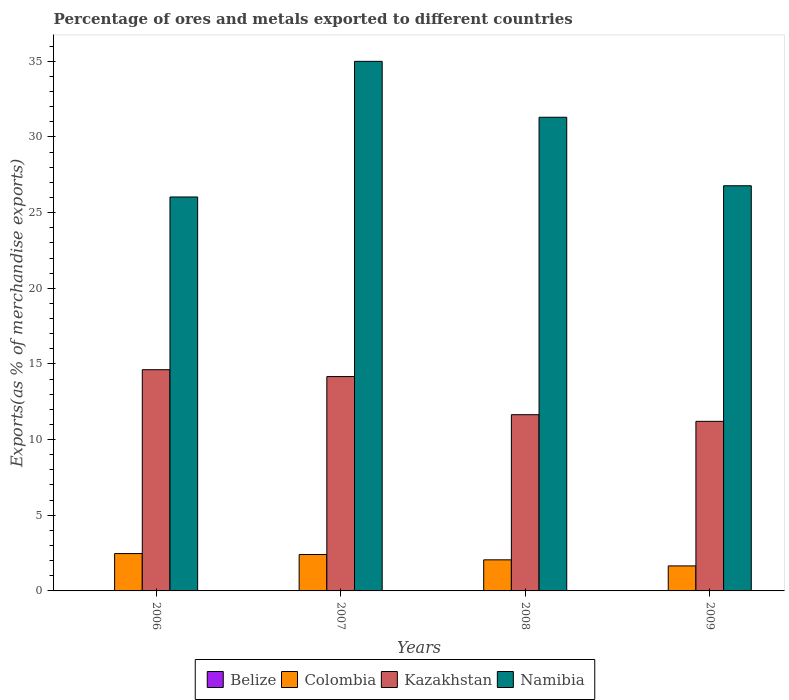Are the number of bars per tick equal to the number of legend labels?
Your answer should be compact. Yes. How many bars are there on the 2nd tick from the left?
Your answer should be very brief. 4. In how many cases, is the number of bars for a given year not equal to the number of legend labels?
Your response must be concise. 0. What is the percentage of exports to different countries in Kazakhstan in 2008?
Offer a very short reply. 11.64. Across all years, what is the maximum percentage of exports to different countries in Namibia?
Keep it short and to the point. 34.99. Across all years, what is the minimum percentage of exports to different countries in Namibia?
Offer a terse response. 26.03. In which year was the percentage of exports to different countries in Kazakhstan maximum?
Make the answer very short. 2006. What is the total percentage of exports to different countries in Colombia in the graph?
Your response must be concise. 8.58. What is the difference between the percentage of exports to different countries in Belize in 2007 and that in 2009?
Provide a succinct answer. 0. What is the difference between the percentage of exports to different countries in Colombia in 2007 and the percentage of exports to different countries in Belize in 2006?
Give a very brief answer. 2.4. What is the average percentage of exports to different countries in Colombia per year?
Provide a succinct answer. 2.15. In the year 2008, what is the difference between the percentage of exports to different countries in Colombia and percentage of exports to different countries in Belize?
Make the answer very short. 2.05. What is the ratio of the percentage of exports to different countries in Kazakhstan in 2007 to that in 2008?
Offer a very short reply. 1.22. Is the percentage of exports to different countries in Colombia in 2006 less than that in 2007?
Ensure brevity in your answer.  No. Is the difference between the percentage of exports to different countries in Colombia in 2008 and 2009 greater than the difference between the percentage of exports to different countries in Belize in 2008 and 2009?
Provide a short and direct response. Yes. What is the difference between the highest and the second highest percentage of exports to different countries in Namibia?
Provide a succinct answer. 3.69. What is the difference between the highest and the lowest percentage of exports to different countries in Namibia?
Offer a terse response. 8.96. Is the sum of the percentage of exports to different countries in Kazakhstan in 2007 and 2008 greater than the maximum percentage of exports to different countries in Colombia across all years?
Offer a terse response. Yes. Is it the case that in every year, the sum of the percentage of exports to different countries in Colombia and percentage of exports to different countries in Kazakhstan is greater than the sum of percentage of exports to different countries in Namibia and percentage of exports to different countries in Belize?
Keep it short and to the point. Yes. What does the 2nd bar from the left in 2006 represents?
Your answer should be very brief. Colombia. What does the 2nd bar from the right in 2008 represents?
Your response must be concise. Kazakhstan. Is it the case that in every year, the sum of the percentage of exports to different countries in Belize and percentage of exports to different countries in Kazakhstan is greater than the percentage of exports to different countries in Colombia?
Your answer should be compact. Yes. Are all the bars in the graph horizontal?
Make the answer very short. No. How many years are there in the graph?
Your response must be concise. 4. What is the difference between two consecutive major ticks on the Y-axis?
Offer a terse response. 5. Are the values on the major ticks of Y-axis written in scientific E-notation?
Provide a succinct answer. No. Does the graph contain any zero values?
Give a very brief answer. No. Does the graph contain grids?
Offer a terse response. No. Where does the legend appear in the graph?
Keep it short and to the point. Bottom center. How many legend labels are there?
Offer a very short reply. 4. What is the title of the graph?
Offer a terse response. Percentage of ores and metals exported to different countries. Does "Ethiopia" appear as one of the legend labels in the graph?
Offer a very short reply. No. What is the label or title of the Y-axis?
Offer a very short reply. Exports(as % of merchandise exports). What is the Exports(as % of merchandise exports) in Belize in 2006?
Give a very brief answer. 0. What is the Exports(as % of merchandise exports) of Colombia in 2006?
Provide a succinct answer. 2.47. What is the Exports(as % of merchandise exports) in Kazakhstan in 2006?
Your answer should be very brief. 14.62. What is the Exports(as % of merchandise exports) in Namibia in 2006?
Offer a very short reply. 26.03. What is the Exports(as % of merchandise exports) of Belize in 2007?
Your answer should be very brief. 0. What is the Exports(as % of merchandise exports) of Colombia in 2007?
Provide a short and direct response. 2.41. What is the Exports(as % of merchandise exports) of Kazakhstan in 2007?
Ensure brevity in your answer.  14.16. What is the Exports(as % of merchandise exports) of Namibia in 2007?
Provide a short and direct response. 34.99. What is the Exports(as % of merchandise exports) in Belize in 2008?
Ensure brevity in your answer.  0. What is the Exports(as % of merchandise exports) in Colombia in 2008?
Give a very brief answer. 2.05. What is the Exports(as % of merchandise exports) of Kazakhstan in 2008?
Your answer should be very brief. 11.64. What is the Exports(as % of merchandise exports) of Namibia in 2008?
Offer a very short reply. 31.3. What is the Exports(as % of merchandise exports) of Belize in 2009?
Offer a terse response. 0. What is the Exports(as % of merchandise exports) in Colombia in 2009?
Provide a short and direct response. 1.65. What is the Exports(as % of merchandise exports) in Kazakhstan in 2009?
Your answer should be very brief. 11.21. What is the Exports(as % of merchandise exports) of Namibia in 2009?
Your response must be concise. 26.77. Across all years, what is the maximum Exports(as % of merchandise exports) in Belize?
Ensure brevity in your answer.  0. Across all years, what is the maximum Exports(as % of merchandise exports) in Colombia?
Make the answer very short. 2.47. Across all years, what is the maximum Exports(as % of merchandise exports) of Kazakhstan?
Your answer should be very brief. 14.62. Across all years, what is the maximum Exports(as % of merchandise exports) of Namibia?
Make the answer very short. 34.99. Across all years, what is the minimum Exports(as % of merchandise exports) in Belize?
Your answer should be very brief. 0. Across all years, what is the minimum Exports(as % of merchandise exports) of Colombia?
Provide a short and direct response. 1.65. Across all years, what is the minimum Exports(as % of merchandise exports) of Kazakhstan?
Your response must be concise. 11.21. Across all years, what is the minimum Exports(as % of merchandise exports) of Namibia?
Offer a terse response. 26.03. What is the total Exports(as % of merchandise exports) in Belize in the graph?
Keep it short and to the point. 0.01. What is the total Exports(as % of merchandise exports) of Colombia in the graph?
Make the answer very short. 8.58. What is the total Exports(as % of merchandise exports) in Kazakhstan in the graph?
Give a very brief answer. 51.63. What is the total Exports(as % of merchandise exports) in Namibia in the graph?
Offer a terse response. 119.1. What is the difference between the Exports(as % of merchandise exports) in Belize in 2006 and that in 2007?
Give a very brief answer. -0. What is the difference between the Exports(as % of merchandise exports) of Colombia in 2006 and that in 2007?
Your answer should be compact. 0.06. What is the difference between the Exports(as % of merchandise exports) of Kazakhstan in 2006 and that in 2007?
Make the answer very short. 0.45. What is the difference between the Exports(as % of merchandise exports) of Namibia in 2006 and that in 2007?
Your answer should be very brief. -8.96. What is the difference between the Exports(as % of merchandise exports) in Belize in 2006 and that in 2008?
Ensure brevity in your answer.  -0. What is the difference between the Exports(as % of merchandise exports) of Colombia in 2006 and that in 2008?
Keep it short and to the point. 0.41. What is the difference between the Exports(as % of merchandise exports) of Kazakhstan in 2006 and that in 2008?
Give a very brief answer. 2.97. What is the difference between the Exports(as % of merchandise exports) in Namibia in 2006 and that in 2008?
Your answer should be compact. -5.27. What is the difference between the Exports(as % of merchandise exports) in Belize in 2006 and that in 2009?
Your answer should be compact. -0. What is the difference between the Exports(as % of merchandise exports) in Colombia in 2006 and that in 2009?
Your response must be concise. 0.81. What is the difference between the Exports(as % of merchandise exports) in Kazakhstan in 2006 and that in 2009?
Your answer should be compact. 3.41. What is the difference between the Exports(as % of merchandise exports) of Namibia in 2006 and that in 2009?
Your answer should be compact. -0.74. What is the difference between the Exports(as % of merchandise exports) in Belize in 2007 and that in 2008?
Your response must be concise. -0. What is the difference between the Exports(as % of merchandise exports) of Colombia in 2007 and that in 2008?
Your response must be concise. 0.35. What is the difference between the Exports(as % of merchandise exports) of Kazakhstan in 2007 and that in 2008?
Your answer should be compact. 2.52. What is the difference between the Exports(as % of merchandise exports) of Namibia in 2007 and that in 2008?
Your response must be concise. 3.69. What is the difference between the Exports(as % of merchandise exports) in Belize in 2007 and that in 2009?
Offer a very short reply. 0. What is the difference between the Exports(as % of merchandise exports) of Colombia in 2007 and that in 2009?
Make the answer very short. 0.75. What is the difference between the Exports(as % of merchandise exports) in Kazakhstan in 2007 and that in 2009?
Make the answer very short. 2.96. What is the difference between the Exports(as % of merchandise exports) of Namibia in 2007 and that in 2009?
Provide a succinct answer. 8.22. What is the difference between the Exports(as % of merchandise exports) in Belize in 2008 and that in 2009?
Offer a terse response. 0. What is the difference between the Exports(as % of merchandise exports) of Colombia in 2008 and that in 2009?
Offer a very short reply. 0.4. What is the difference between the Exports(as % of merchandise exports) of Kazakhstan in 2008 and that in 2009?
Your answer should be compact. 0.44. What is the difference between the Exports(as % of merchandise exports) in Namibia in 2008 and that in 2009?
Make the answer very short. 4.53. What is the difference between the Exports(as % of merchandise exports) in Belize in 2006 and the Exports(as % of merchandise exports) in Colombia in 2007?
Give a very brief answer. -2.4. What is the difference between the Exports(as % of merchandise exports) of Belize in 2006 and the Exports(as % of merchandise exports) of Kazakhstan in 2007?
Give a very brief answer. -14.16. What is the difference between the Exports(as % of merchandise exports) in Belize in 2006 and the Exports(as % of merchandise exports) in Namibia in 2007?
Make the answer very short. -34.99. What is the difference between the Exports(as % of merchandise exports) of Colombia in 2006 and the Exports(as % of merchandise exports) of Kazakhstan in 2007?
Keep it short and to the point. -11.7. What is the difference between the Exports(as % of merchandise exports) of Colombia in 2006 and the Exports(as % of merchandise exports) of Namibia in 2007?
Provide a short and direct response. -32.53. What is the difference between the Exports(as % of merchandise exports) of Kazakhstan in 2006 and the Exports(as % of merchandise exports) of Namibia in 2007?
Your response must be concise. -20.38. What is the difference between the Exports(as % of merchandise exports) of Belize in 2006 and the Exports(as % of merchandise exports) of Colombia in 2008?
Offer a terse response. -2.05. What is the difference between the Exports(as % of merchandise exports) of Belize in 2006 and the Exports(as % of merchandise exports) of Kazakhstan in 2008?
Offer a terse response. -11.64. What is the difference between the Exports(as % of merchandise exports) in Belize in 2006 and the Exports(as % of merchandise exports) in Namibia in 2008?
Keep it short and to the point. -31.3. What is the difference between the Exports(as % of merchandise exports) in Colombia in 2006 and the Exports(as % of merchandise exports) in Kazakhstan in 2008?
Make the answer very short. -9.18. What is the difference between the Exports(as % of merchandise exports) in Colombia in 2006 and the Exports(as % of merchandise exports) in Namibia in 2008?
Offer a terse response. -28.83. What is the difference between the Exports(as % of merchandise exports) of Kazakhstan in 2006 and the Exports(as % of merchandise exports) of Namibia in 2008?
Give a very brief answer. -16.68. What is the difference between the Exports(as % of merchandise exports) of Belize in 2006 and the Exports(as % of merchandise exports) of Colombia in 2009?
Your response must be concise. -1.65. What is the difference between the Exports(as % of merchandise exports) in Belize in 2006 and the Exports(as % of merchandise exports) in Kazakhstan in 2009?
Your response must be concise. -11.21. What is the difference between the Exports(as % of merchandise exports) of Belize in 2006 and the Exports(as % of merchandise exports) of Namibia in 2009?
Your answer should be compact. -26.77. What is the difference between the Exports(as % of merchandise exports) of Colombia in 2006 and the Exports(as % of merchandise exports) of Kazakhstan in 2009?
Your answer should be very brief. -8.74. What is the difference between the Exports(as % of merchandise exports) in Colombia in 2006 and the Exports(as % of merchandise exports) in Namibia in 2009?
Your response must be concise. -24.31. What is the difference between the Exports(as % of merchandise exports) of Kazakhstan in 2006 and the Exports(as % of merchandise exports) of Namibia in 2009?
Make the answer very short. -12.15. What is the difference between the Exports(as % of merchandise exports) in Belize in 2007 and the Exports(as % of merchandise exports) in Colombia in 2008?
Provide a succinct answer. -2.05. What is the difference between the Exports(as % of merchandise exports) of Belize in 2007 and the Exports(as % of merchandise exports) of Kazakhstan in 2008?
Offer a terse response. -11.64. What is the difference between the Exports(as % of merchandise exports) of Belize in 2007 and the Exports(as % of merchandise exports) of Namibia in 2008?
Provide a succinct answer. -31.3. What is the difference between the Exports(as % of merchandise exports) of Colombia in 2007 and the Exports(as % of merchandise exports) of Kazakhstan in 2008?
Provide a succinct answer. -9.24. What is the difference between the Exports(as % of merchandise exports) in Colombia in 2007 and the Exports(as % of merchandise exports) in Namibia in 2008?
Keep it short and to the point. -28.9. What is the difference between the Exports(as % of merchandise exports) in Kazakhstan in 2007 and the Exports(as % of merchandise exports) in Namibia in 2008?
Your answer should be very brief. -17.14. What is the difference between the Exports(as % of merchandise exports) in Belize in 2007 and the Exports(as % of merchandise exports) in Colombia in 2009?
Ensure brevity in your answer.  -1.65. What is the difference between the Exports(as % of merchandise exports) of Belize in 2007 and the Exports(as % of merchandise exports) of Kazakhstan in 2009?
Offer a very short reply. -11.2. What is the difference between the Exports(as % of merchandise exports) of Belize in 2007 and the Exports(as % of merchandise exports) of Namibia in 2009?
Offer a terse response. -26.77. What is the difference between the Exports(as % of merchandise exports) of Colombia in 2007 and the Exports(as % of merchandise exports) of Kazakhstan in 2009?
Your answer should be compact. -8.8. What is the difference between the Exports(as % of merchandise exports) of Colombia in 2007 and the Exports(as % of merchandise exports) of Namibia in 2009?
Your answer should be compact. -24.37. What is the difference between the Exports(as % of merchandise exports) of Kazakhstan in 2007 and the Exports(as % of merchandise exports) of Namibia in 2009?
Ensure brevity in your answer.  -12.61. What is the difference between the Exports(as % of merchandise exports) of Belize in 2008 and the Exports(as % of merchandise exports) of Colombia in 2009?
Make the answer very short. -1.65. What is the difference between the Exports(as % of merchandise exports) of Belize in 2008 and the Exports(as % of merchandise exports) of Kazakhstan in 2009?
Your answer should be compact. -11.2. What is the difference between the Exports(as % of merchandise exports) of Belize in 2008 and the Exports(as % of merchandise exports) of Namibia in 2009?
Offer a very short reply. -26.77. What is the difference between the Exports(as % of merchandise exports) in Colombia in 2008 and the Exports(as % of merchandise exports) in Kazakhstan in 2009?
Keep it short and to the point. -9.15. What is the difference between the Exports(as % of merchandise exports) in Colombia in 2008 and the Exports(as % of merchandise exports) in Namibia in 2009?
Ensure brevity in your answer.  -24.72. What is the difference between the Exports(as % of merchandise exports) of Kazakhstan in 2008 and the Exports(as % of merchandise exports) of Namibia in 2009?
Your answer should be compact. -15.13. What is the average Exports(as % of merchandise exports) in Belize per year?
Keep it short and to the point. 0. What is the average Exports(as % of merchandise exports) of Colombia per year?
Offer a terse response. 2.15. What is the average Exports(as % of merchandise exports) in Kazakhstan per year?
Your answer should be very brief. 12.91. What is the average Exports(as % of merchandise exports) in Namibia per year?
Offer a terse response. 29.78. In the year 2006, what is the difference between the Exports(as % of merchandise exports) of Belize and Exports(as % of merchandise exports) of Colombia?
Your answer should be compact. -2.47. In the year 2006, what is the difference between the Exports(as % of merchandise exports) in Belize and Exports(as % of merchandise exports) in Kazakhstan?
Give a very brief answer. -14.62. In the year 2006, what is the difference between the Exports(as % of merchandise exports) of Belize and Exports(as % of merchandise exports) of Namibia?
Provide a succinct answer. -26.03. In the year 2006, what is the difference between the Exports(as % of merchandise exports) in Colombia and Exports(as % of merchandise exports) in Kazakhstan?
Your answer should be very brief. -12.15. In the year 2006, what is the difference between the Exports(as % of merchandise exports) in Colombia and Exports(as % of merchandise exports) in Namibia?
Offer a very short reply. -23.56. In the year 2006, what is the difference between the Exports(as % of merchandise exports) in Kazakhstan and Exports(as % of merchandise exports) in Namibia?
Make the answer very short. -11.41. In the year 2007, what is the difference between the Exports(as % of merchandise exports) in Belize and Exports(as % of merchandise exports) in Colombia?
Offer a terse response. -2.4. In the year 2007, what is the difference between the Exports(as % of merchandise exports) of Belize and Exports(as % of merchandise exports) of Kazakhstan?
Offer a very short reply. -14.16. In the year 2007, what is the difference between the Exports(as % of merchandise exports) in Belize and Exports(as % of merchandise exports) in Namibia?
Keep it short and to the point. -34.99. In the year 2007, what is the difference between the Exports(as % of merchandise exports) in Colombia and Exports(as % of merchandise exports) in Kazakhstan?
Provide a succinct answer. -11.76. In the year 2007, what is the difference between the Exports(as % of merchandise exports) of Colombia and Exports(as % of merchandise exports) of Namibia?
Provide a short and direct response. -32.59. In the year 2007, what is the difference between the Exports(as % of merchandise exports) of Kazakhstan and Exports(as % of merchandise exports) of Namibia?
Offer a terse response. -20.83. In the year 2008, what is the difference between the Exports(as % of merchandise exports) in Belize and Exports(as % of merchandise exports) in Colombia?
Make the answer very short. -2.05. In the year 2008, what is the difference between the Exports(as % of merchandise exports) in Belize and Exports(as % of merchandise exports) in Kazakhstan?
Your answer should be compact. -11.64. In the year 2008, what is the difference between the Exports(as % of merchandise exports) in Belize and Exports(as % of merchandise exports) in Namibia?
Your response must be concise. -31.3. In the year 2008, what is the difference between the Exports(as % of merchandise exports) in Colombia and Exports(as % of merchandise exports) in Kazakhstan?
Your answer should be very brief. -9.59. In the year 2008, what is the difference between the Exports(as % of merchandise exports) of Colombia and Exports(as % of merchandise exports) of Namibia?
Your answer should be compact. -29.25. In the year 2008, what is the difference between the Exports(as % of merchandise exports) in Kazakhstan and Exports(as % of merchandise exports) in Namibia?
Provide a succinct answer. -19.66. In the year 2009, what is the difference between the Exports(as % of merchandise exports) of Belize and Exports(as % of merchandise exports) of Colombia?
Ensure brevity in your answer.  -1.65. In the year 2009, what is the difference between the Exports(as % of merchandise exports) of Belize and Exports(as % of merchandise exports) of Kazakhstan?
Offer a very short reply. -11.21. In the year 2009, what is the difference between the Exports(as % of merchandise exports) of Belize and Exports(as % of merchandise exports) of Namibia?
Offer a very short reply. -26.77. In the year 2009, what is the difference between the Exports(as % of merchandise exports) of Colombia and Exports(as % of merchandise exports) of Kazakhstan?
Your response must be concise. -9.55. In the year 2009, what is the difference between the Exports(as % of merchandise exports) of Colombia and Exports(as % of merchandise exports) of Namibia?
Offer a very short reply. -25.12. In the year 2009, what is the difference between the Exports(as % of merchandise exports) in Kazakhstan and Exports(as % of merchandise exports) in Namibia?
Give a very brief answer. -15.57. What is the ratio of the Exports(as % of merchandise exports) of Belize in 2006 to that in 2007?
Your response must be concise. 0.15. What is the ratio of the Exports(as % of merchandise exports) in Colombia in 2006 to that in 2007?
Offer a terse response. 1.03. What is the ratio of the Exports(as % of merchandise exports) of Kazakhstan in 2006 to that in 2007?
Ensure brevity in your answer.  1.03. What is the ratio of the Exports(as % of merchandise exports) of Namibia in 2006 to that in 2007?
Give a very brief answer. 0.74. What is the ratio of the Exports(as % of merchandise exports) of Belize in 2006 to that in 2008?
Keep it short and to the point. 0.06. What is the ratio of the Exports(as % of merchandise exports) of Colombia in 2006 to that in 2008?
Your answer should be very brief. 1.2. What is the ratio of the Exports(as % of merchandise exports) in Kazakhstan in 2006 to that in 2008?
Offer a terse response. 1.26. What is the ratio of the Exports(as % of merchandise exports) in Namibia in 2006 to that in 2008?
Offer a very short reply. 0.83. What is the ratio of the Exports(as % of merchandise exports) of Belize in 2006 to that in 2009?
Make the answer very short. 0.67. What is the ratio of the Exports(as % of merchandise exports) in Colombia in 2006 to that in 2009?
Your response must be concise. 1.49. What is the ratio of the Exports(as % of merchandise exports) of Kazakhstan in 2006 to that in 2009?
Keep it short and to the point. 1.3. What is the ratio of the Exports(as % of merchandise exports) of Namibia in 2006 to that in 2009?
Your response must be concise. 0.97. What is the ratio of the Exports(as % of merchandise exports) in Belize in 2007 to that in 2008?
Your response must be concise. 0.41. What is the ratio of the Exports(as % of merchandise exports) of Colombia in 2007 to that in 2008?
Offer a very short reply. 1.17. What is the ratio of the Exports(as % of merchandise exports) in Kazakhstan in 2007 to that in 2008?
Ensure brevity in your answer.  1.22. What is the ratio of the Exports(as % of merchandise exports) in Namibia in 2007 to that in 2008?
Your response must be concise. 1.12. What is the ratio of the Exports(as % of merchandise exports) of Belize in 2007 to that in 2009?
Offer a very short reply. 4.46. What is the ratio of the Exports(as % of merchandise exports) of Colombia in 2007 to that in 2009?
Keep it short and to the point. 1.45. What is the ratio of the Exports(as % of merchandise exports) of Kazakhstan in 2007 to that in 2009?
Provide a succinct answer. 1.26. What is the ratio of the Exports(as % of merchandise exports) of Namibia in 2007 to that in 2009?
Ensure brevity in your answer.  1.31. What is the ratio of the Exports(as % of merchandise exports) of Belize in 2008 to that in 2009?
Offer a terse response. 10.83. What is the ratio of the Exports(as % of merchandise exports) of Colombia in 2008 to that in 2009?
Provide a succinct answer. 1.24. What is the ratio of the Exports(as % of merchandise exports) of Kazakhstan in 2008 to that in 2009?
Offer a very short reply. 1.04. What is the ratio of the Exports(as % of merchandise exports) in Namibia in 2008 to that in 2009?
Provide a succinct answer. 1.17. What is the difference between the highest and the second highest Exports(as % of merchandise exports) of Belize?
Offer a terse response. 0. What is the difference between the highest and the second highest Exports(as % of merchandise exports) of Colombia?
Your answer should be very brief. 0.06. What is the difference between the highest and the second highest Exports(as % of merchandise exports) in Kazakhstan?
Provide a succinct answer. 0.45. What is the difference between the highest and the second highest Exports(as % of merchandise exports) of Namibia?
Offer a terse response. 3.69. What is the difference between the highest and the lowest Exports(as % of merchandise exports) of Belize?
Give a very brief answer. 0. What is the difference between the highest and the lowest Exports(as % of merchandise exports) in Colombia?
Give a very brief answer. 0.81. What is the difference between the highest and the lowest Exports(as % of merchandise exports) in Kazakhstan?
Your response must be concise. 3.41. What is the difference between the highest and the lowest Exports(as % of merchandise exports) in Namibia?
Offer a terse response. 8.96. 